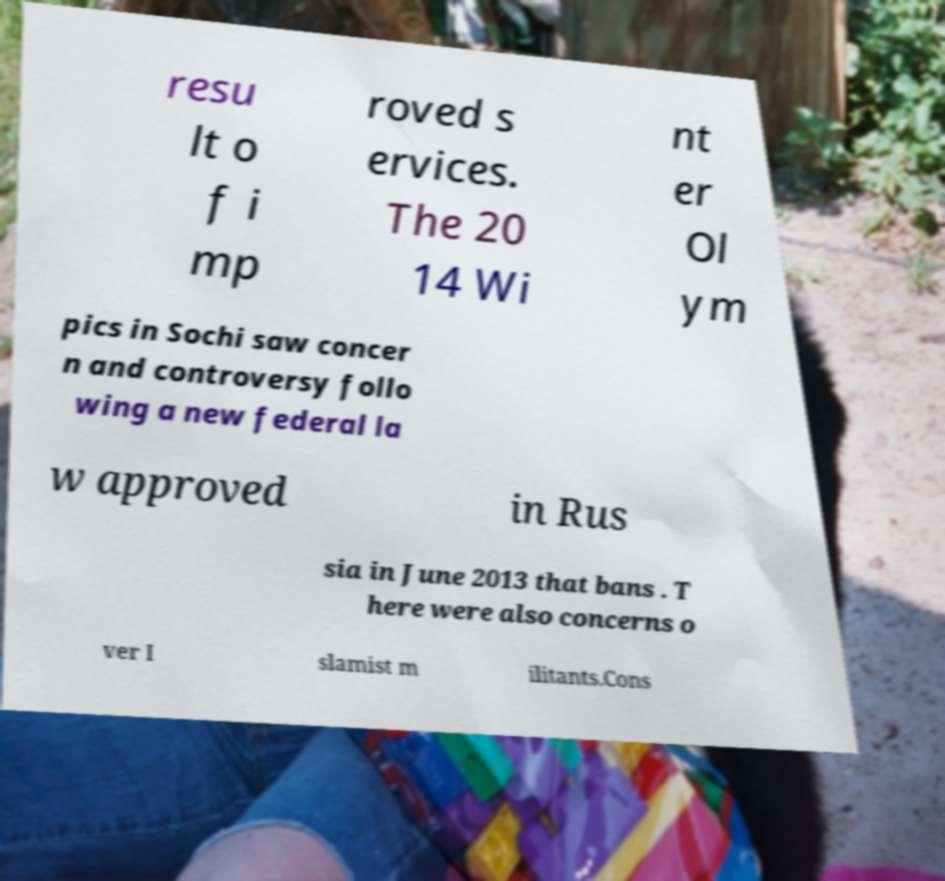Please identify and transcribe the text found in this image. resu lt o f i mp roved s ervices. The 20 14 Wi nt er Ol ym pics in Sochi saw concer n and controversy follo wing a new federal la w approved in Rus sia in June 2013 that bans . T here were also concerns o ver I slamist m ilitants.Cons 